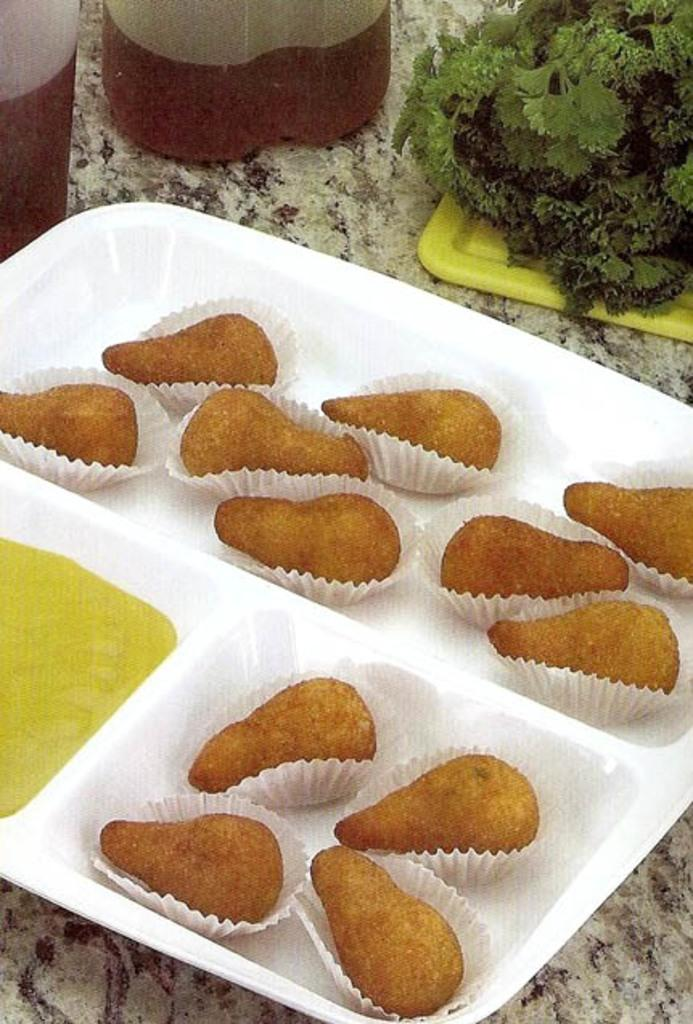What is present on the plate in the image? There is food placed on a plate in the image. How is the food wrapped in the image? The food is wrapped in papers. What can be seen in the background of the image? There are plants and bottles containing liquid in the background of the image. Where are the bottles placed in the image? The bottles are placed on a surface in the background. What is the size of the canvas in the image? There is no canvas present in the image. What does the food smell like in the image? The image does not provide information about the smell of the food. 